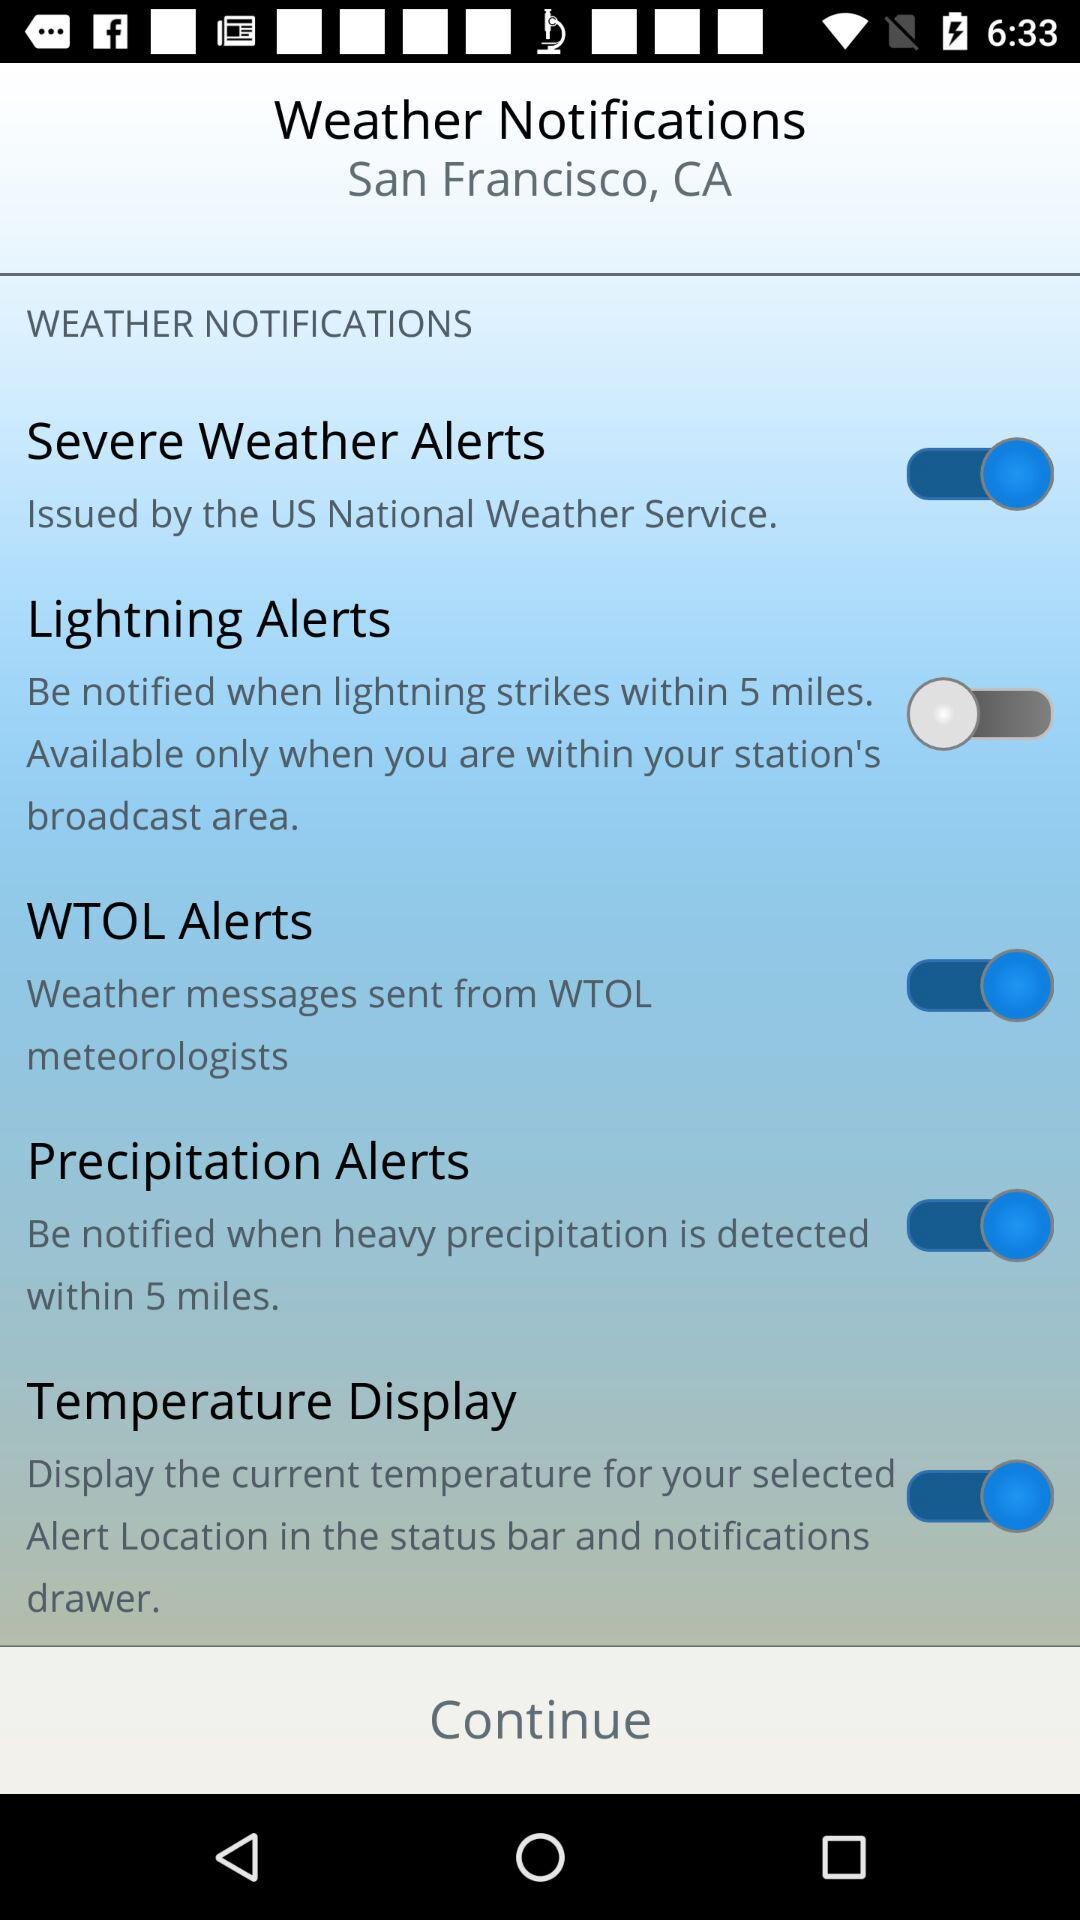What is the status of the "Severe Weather Alerts"? The status is "on". 